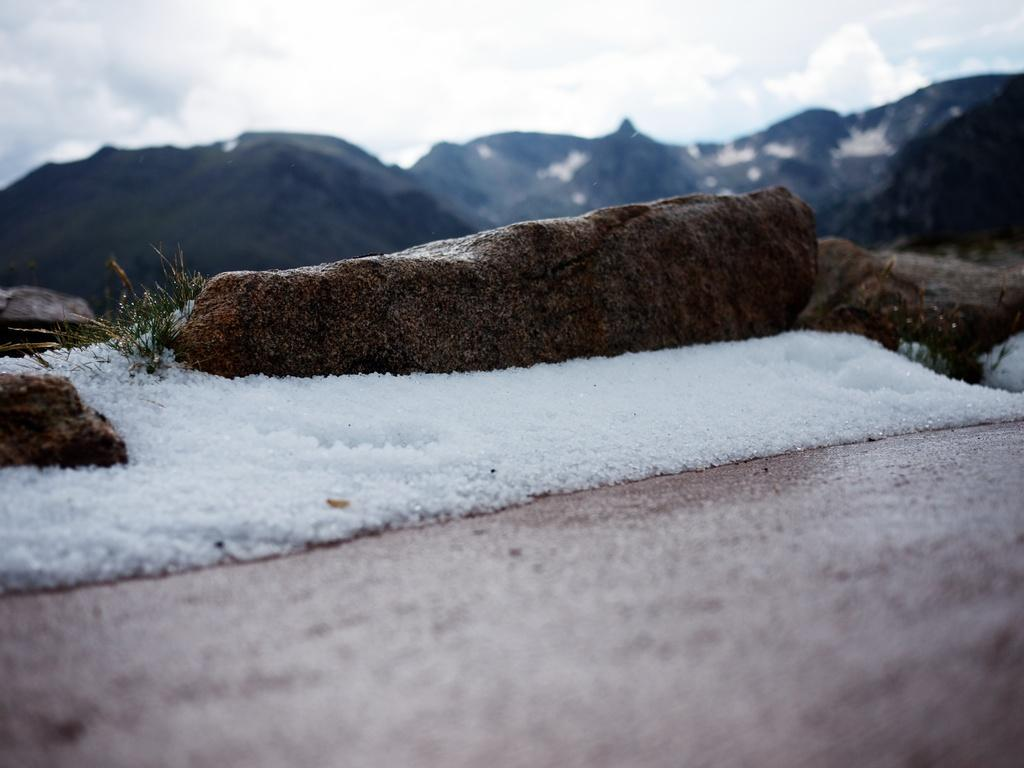What is the primary feature of the landscape in the image? There is snow in the image. What other elements can be seen in the landscape? There are rocks in the image. What can be seen in the distance in the image? In the background of the image, there are mountains. Where is the glue being used in the image? There is no glue present in the image. Can you see a monkey climbing one of the rocks in the image? There is no monkey present in the image. 